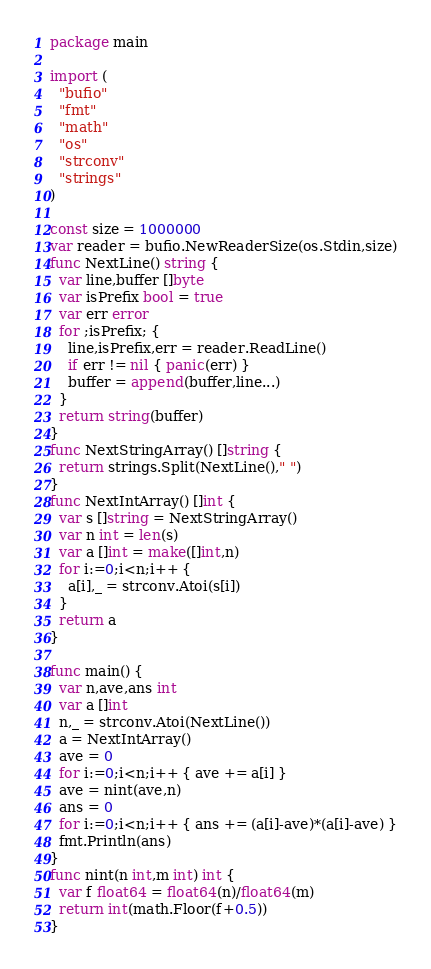<code> <loc_0><loc_0><loc_500><loc_500><_Go_>package main

import (
  "bufio"
  "fmt"
  "math"
  "os"
  "strconv"
  "strings"
)

const size = 1000000
var reader = bufio.NewReaderSize(os.Stdin,size)
func NextLine() string {
  var line,buffer []byte
  var isPrefix bool = true
  var err error
  for ;isPrefix; {
    line,isPrefix,err = reader.ReadLine()
    if err != nil { panic(err) }
    buffer = append(buffer,line...)
  }
  return string(buffer)
}
func NextStringArray() []string {
  return strings.Split(NextLine()," ")
}
func NextIntArray() []int {
  var s []string = NextStringArray()
  var n int = len(s)
  var a []int = make([]int,n)
  for i:=0;i<n;i++ {
    a[i],_ = strconv.Atoi(s[i])
  }
  return a
}

func main() {
  var n,ave,ans int
  var a []int
  n,_ = strconv.Atoi(NextLine())
  a = NextIntArray()
  ave = 0
  for i:=0;i<n;i++ { ave += a[i] }
  ave = nint(ave,n)
  ans = 0
  for i:=0;i<n;i++ { ans += (a[i]-ave)*(a[i]-ave) }
  fmt.Println(ans)
}
func nint(n int,m int) int {
  var f float64 = float64(n)/float64(m)
  return int(math.Floor(f+0.5))
}</code> 